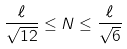Convert formula to latex. <formula><loc_0><loc_0><loc_500><loc_500>\frac { \ell } { \sqrt { 1 2 } } \leq N \leq \frac { \ell } { \sqrt { 6 } }</formula> 